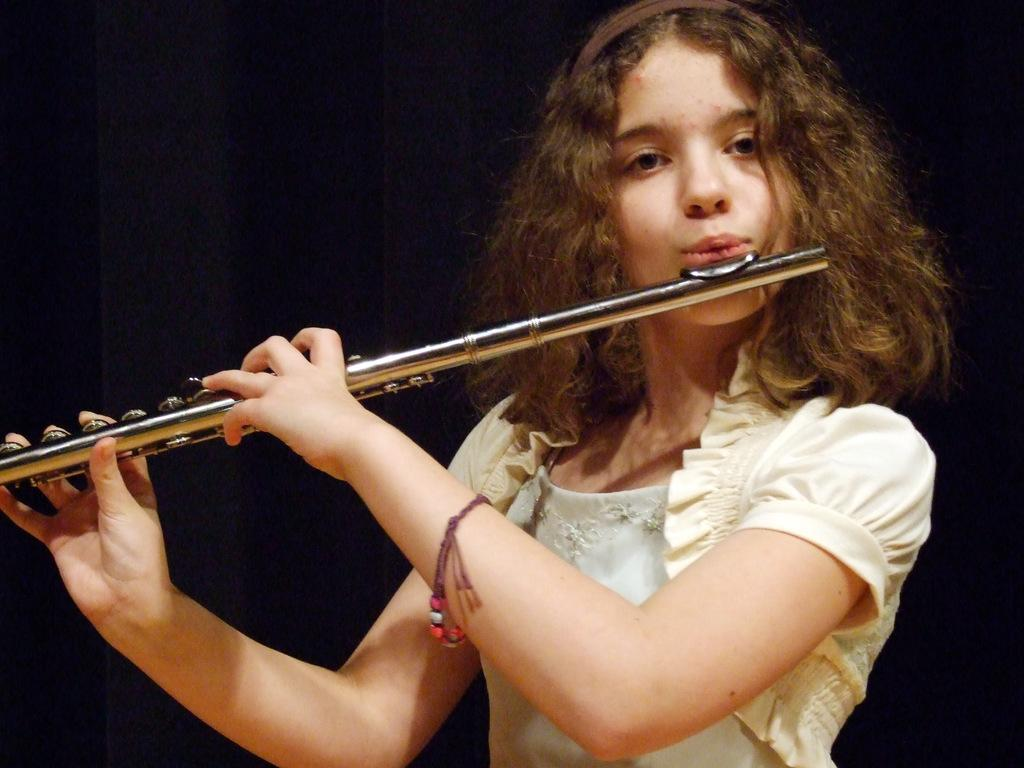Who is the main subject in the image? There is a girl in the image. What is the girl doing in the image? The girl is playing a flute. Can you describe the background of the image? The background of the image is dark. What type of surprise can be seen in the image? There is no surprise present in the image; it features a girl playing a flute against a dark background. 